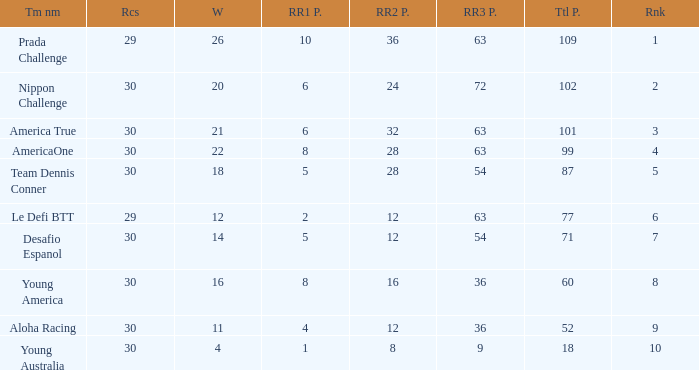Name the ranking for rr2 pts being 8 10.0. 